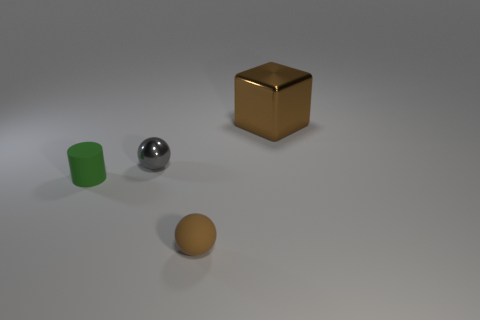Is the number of large cubes on the left side of the small cylinder the same as the number of tiny gray shiny things behind the small metal ball?
Make the answer very short. Yes. Are there any tiny matte spheres left of the metal object in front of the block?
Ensure brevity in your answer.  No. The small gray object has what shape?
Give a very brief answer. Sphere. What size is the thing that is the same color as the block?
Offer a terse response. Small. What is the size of the brown object that is in front of the brown cube that is to the right of the tiny gray metallic ball?
Make the answer very short. Small. There is a thing that is to the left of the tiny gray metallic sphere; what is its size?
Offer a terse response. Small. Are there fewer things in front of the small brown thing than gray metal objects on the right side of the large metal block?
Offer a very short reply. No. What is the color of the cube?
Offer a terse response. Brown. Is there a small rubber ball of the same color as the small shiny sphere?
Ensure brevity in your answer.  No. There is a matte thing that is on the left side of the small sphere that is behind the matte object behind the tiny brown thing; what shape is it?
Make the answer very short. Cylinder. 